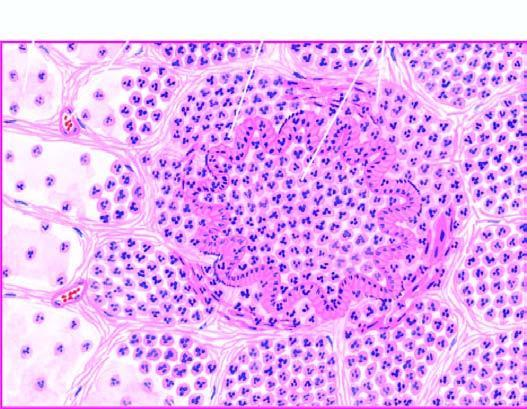re mutations in membrane proteins-alpha-spectrin, beta-spectrin and ankyrin, filled with exudate consisting chiefly of neutrophils?
Answer the question using a single word or phrase. No 